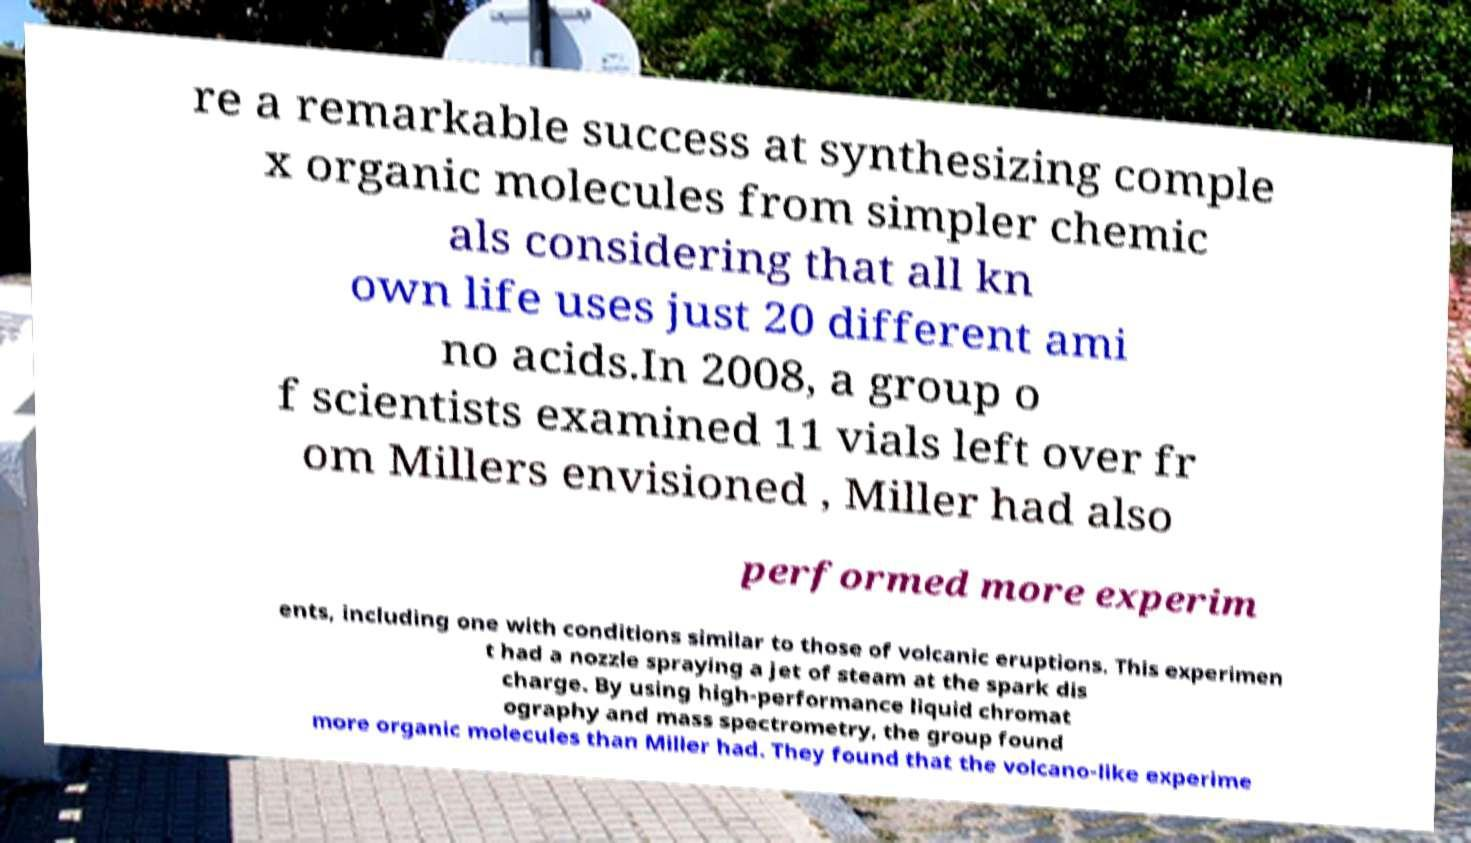There's text embedded in this image that I need extracted. Can you transcribe it verbatim? re a remarkable success at synthesizing comple x organic molecules from simpler chemic als considering that all kn own life uses just 20 different ami no acids.In 2008, a group o f scientists examined 11 vials left over fr om Millers envisioned , Miller had also performed more experim ents, including one with conditions similar to those of volcanic eruptions. This experimen t had a nozzle spraying a jet of steam at the spark dis charge. By using high-performance liquid chromat ography and mass spectrometry, the group found more organic molecules than Miller had. They found that the volcano-like experime 